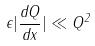<formula> <loc_0><loc_0><loc_500><loc_500>\epsilon | \frac { d Q } { d x } | \ll Q ^ { 2 }</formula> 